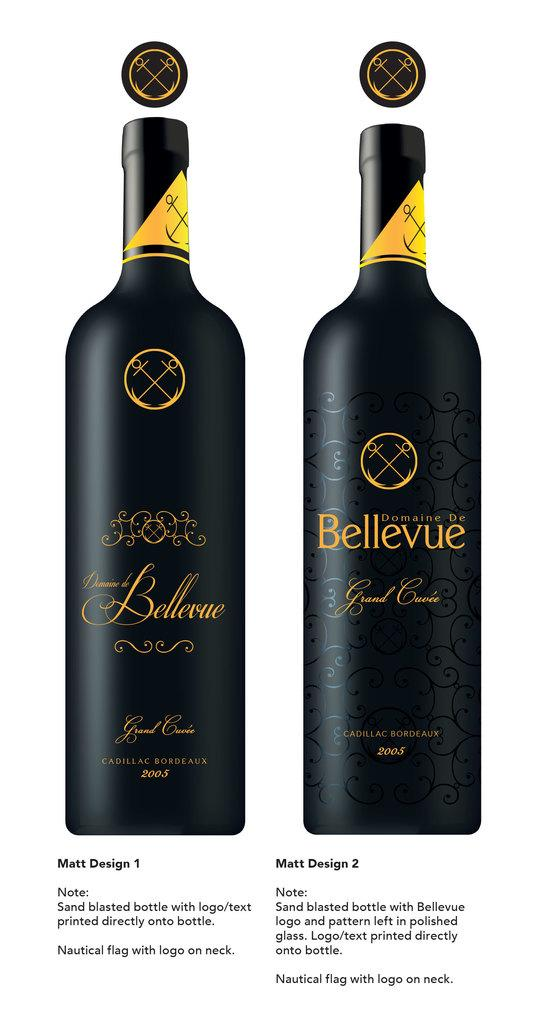Provide a one-sentence caption for the provided image. Two designs for a bottle of Bellevue and a description of how it was done. 